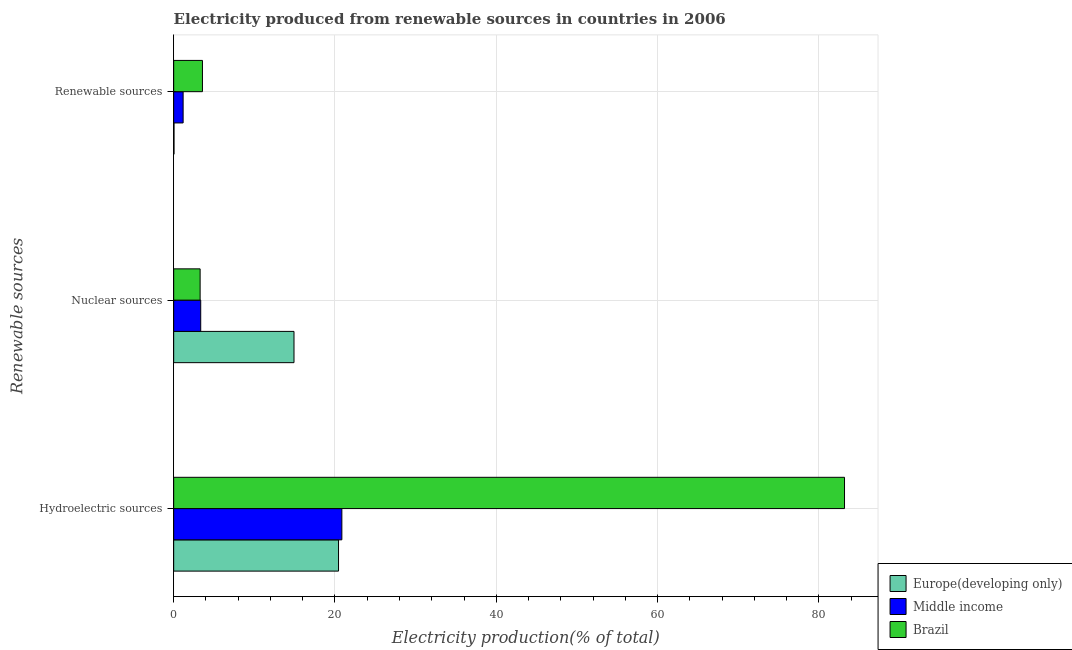How many groups of bars are there?
Give a very brief answer. 3. Are the number of bars per tick equal to the number of legend labels?
Make the answer very short. Yes. What is the label of the 2nd group of bars from the top?
Give a very brief answer. Nuclear sources. What is the percentage of electricity produced by hydroelectric sources in Europe(developing only)?
Your answer should be very brief. 20.44. Across all countries, what is the maximum percentage of electricity produced by nuclear sources?
Ensure brevity in your answer.  14.92. Across all countries, what is the minimum percentage of electricity produced by nuclear sources?
Make the answer very short. 3.28. In which country was the percentage of electricity produced by nuclear sources maximum?
Offer a terse response. Europe(developing only). In which country was the percentage of electricity produced by renewable sources minimum?
Provide a short and direct response. Europe(developing only). What is the total percentage of electricity produced by renewable sources in the graph?
Your answer should be very brief. 4.78. What is the difference between the percentage of electricity produced by hydroelectric sources in Middle income and that in Brazil?
Your answer should be compact. -62.33. What is the difference between the percentage of electricity produced by nuclear sources in Middle income and the percentage of electricity produced by hydroelectric sources in Europe(developing only)?
Provide a succinct answer. -17.09. What is the average percentage of electricity produced by hydroelectric sources per country?
Ensure brevity in your answer.  41.49. What is the difference between the percentage of electricity produced by hydroelectric sources and percentage of electricity produced by nuclear sources in Middle income?
Your answer should be very brief. 17.5. In how many countries, is the percentage of electricity produced by nuclear sources greater than 64 %?
Provide a short and direct response. 0. What is the ratio of the percentage of electricity produced by renewable sources in Middle income to that in Europe(developing only)?
Offer a terse response. 27.25. What is the difference between the highest and the second highest percentage of electricity produced by renewable sources?
Give a very brief answer. 2.4. What is the difference between the highest and the lowest percentage of electricity produced by hydroelectric sources?
Give a very brief answer. 62.74. Is the sum of the percentage of electricity produced by hydroelectric sources in Middle income and Europe(developing only) greater than the maximum percentage of electricity produced by renewable sources across all countries?
Offer a very short reply. Yes. What does the 3rd bar from the top in Renewable sources represents?
Your answer should be very brief. Europe(developing only). What does the 2nd bar from the bottom in Nuclear sources represents?
Make the answer very short. Middle income. Is it the case that in every country, the sum of the percentage of electricity produced by hydroelectric sources and percentage of electricity produced by nuclear sources is greater than the percentage of electricity produced by renewable sources?
Your answer should be very brief. Yes. Are all the bars in the graph horizontal?
Make the answer very short. Yes. How many countries are there in the graph?
Your answer should be compact. 3. What is the difference between two consecutive major ticks on the X-axis?
Give a very brief answer. 20. Are the values on the major ticks of X-axis written in scientific E-notation?
Your response must be concise. No. Does the graph contain grids?
Ensure brevity in your answer.  Yes. Where does the legend appear in the graph?
Keep it short and to the point. Bottom right. What is the title of the graph?
Give a very brief answer. Electricity produced from renewable sources in countries in 2006. What is the label or title of the Y-axis?
Your answer should be compact. Renewable sources. What is the Electricity production(% of total) in Europe(developing only) in Hydroelectric sources?
Your answer should be very brief. 20.44. What is the Electricity production(% of total) of Middle income in Hydroelectric sources?
Your response must be concise. 20.85. What is the Electricity production(% of total) of Brazil in Hydroelectric sources?
Offer a very short reply. 83.18. What is the Electricity production(% of total) of Europe(developing only) in Nuclear sources?
Offer a very short reply. 14.92. What is the Electricity production(% of total) of Middle income in Nuclear sources?
Your answer should be compact. 3.35. What is the Electricity production(% of total) in Brazil in Nuclear sources?
Make the answer very short. 3.28. What is the Electricity production(% of total) in Europe(developing only) in Renewable sources?
Your response must be concise. 0.04. What is the Electricity production(% of total) in Middle income in Renewable sources?
Your answer should be very brief. 1.17. What is the Electricity production(% of total) of Brazil in Renewable sources?
Give a very brief answer. 3.57. Across all Renewable sources, what is the maximum Electricity production(% of total) of Europe(developing only)?
Your response must be concise. 20.44. Across all Renewable sources, what is the maximum Electricity production(% of total) of Middle income?
Offer a very short reply. 20.85. Across all Renewable sources, what is the maximum Electricity production(% of total) in Brazil?
Give a very brief answer. 83.18. Across all Renewable sources, what is the minimum Electricity production(% of total) of Europe(developing only)?
Your answer should be compact. 0.04. Across all Renewable sources, what is the minimum Electricity production(% of total) in Middle income?
Offer a very short reply. 1.17. Across all Renewable sources, what is the minimum Electricity production(% of total) in Brazil?
Provide a short and direct response. 3.28. What is the total Electricity production(% of total) in Europe(developing only) in the graph?
Provide a short and direct response. 35.41. What is the total Electricity production(% of total) in Middle income in the graph?
Your answer should be very brief. 25.38. What is the total Electricity production(% of total) of Brazil in the graph?
Ensure brevity in your answer.  90.03. What is the difference between the Electricity production(% of total) in Europe(developing only) in Hydroelectric sources and that in Nuclear sources?
Offer a very short reply. 5.52. What is the difference between the Electricity production(% of total) in Middle income in Hydroelectric sources and that in Nuclear sources?
Provide a succinct answer. 17.5. What is the difference between the Electricity production(% of total) in Brazil in Hydroelectric sources and that in Nuclear sources?
Ensure brevity in your answer.  79.9. What is the difference between the Electricity production(% of total) in Europe(developing only) in Hydroelectric sources and that in Renewable sources?
Your response must be concise. 20.4. What is the difference between the Electricity production(% of total) of Middle income in Hydroelectric sources and that in Renewable sources?
Your answer should be compact. 19.68. What is the difference between the Electricity production(% of total) of Brazil in Hydroelectric sources and that in Renewable sources?
Your answer should be compact. 79.61. What is the difference between the Electricity production(% of total) of Europe(developing only) in Nuclear sources and that in Renewable sources?
Ensure brevity in your answer.  14.88. What is the difference between the Electricity production(% of total) of Middle income in Nuclear sources and that in Renewable sources?
Give a very brief answer. 2.18. What is the difference between the Electricity production(% of total) in Brazil in Nuclear sources and that in Renewable sources?
Your response must be concise. -0.29. What is the difference between the Electricity production(% of total) of Europe(developing only) in Hydroelectric sources and the Electricity production(% of total) of Middle income in Nuclear sources?
Offer a very short reply. 17.09. What is the difference between the Electricity production(% of total) of Europe(developing only) in Hydroelectric sources and the Electricity production(% of total) of Brazil in Nuclear sources?
Offer a very short reply. 17.16. What is the difference between the Electricity production(% of total) of Middle income in Hydroelectric sources and the Electricity production(% of total) of Brazil in Nuclear sources?
Make the answer very short. 17.57. What is the difference between the Electricity production(% of total) of Europe(developing only) in Hydroelectric sources and the Electricity production(% of total) of Middle income in Renewable sources?
Provide a succinct answer. 19.27. What is the difference between the Electricity production(% of total) in Europe(developing only) in Hydroelectric sources and the Electricity production(% of total) in Brazil in Renewable sources?
Provide a succinct answer. 16.87. What is the difference between the Electricity production(% of total) of Middle income in Hydroelectric sources and the Electricity production(% of total) of Brazil in Renewable sources?
Give a very brief answer. 17.29. What is the difference between the Electricity production(% of total) of Europe(developing only) in Nuclear sources and the Electricity production(% of total) of Middle income in Renewable sources?
Offer a very short reply. 13.75. What is the difference between the Electricity production(% of total) in Europe(developing only) in Nuclear sources and the Electricity production(% of total) in Brazil in Renewable sources?
Keep it short and to the point. 11.35. What is the difference between the Electricity production(% of total) of Middle income in Nuclear sources and the Electricity production(% of total) of Brazil in Renewable sources?
Your response must be concise. -0.21. What is the average Electricity production(% of total) in Europe(developing only) per Renewable sources?
Your response must be concise. 11.8. What is the average Electricity production(% of total) in Middle income per Renewable sources?
Provide a short and direct response. 8.46. What is the average Electricity production(% of total) of Brazil per Renewable sources?
Your answer should be very brief. 30.01. What is the difference between the Electricity production(% of total) of Europe(developing only) and Electricity production(% of total) of Middle income in Hydroelectric sources?
Your answer should be compact. -0.41. What is the difference between the Electricity production(% of total) of Europe(developing only) and Electricity production(% of total) of Brazil in Hydroelectric sources?
Make the answer very short. -62.74. What is the difference between the Electricity production(% of total) in Middle income and Electricity production(% of total) in Brazil in Hydroelectric sources?
Keep it short and to the point. -62.33. What is the difference between the Electricity production(% of total) of Europe(developing only) and Electricity production(% of total) of Middle income in Nuclear sources?
Give a very brief answer. 11.57. What is the difference between the Electricity production(% of total) in Europe(developing only) and Electricity production(% of total) in Brazil in Nuclear sources?
Your answer should be compact. 11.64. What is the difference between the Electricity production(% of total) of Middle income and Electricity production(% of total) of Brazil in Nuclear sources?
Offer a terse response. 0.07. What is the difference between the Electricity production(% of total) of Europe(developing only) and Electricity production(% of total) of Middle income in Renewable sources?
Your answer should be very brief. -1.13. What is the difference between the Electricity production(% of total) in Europe(developing only) and Electricity production(% of total) in Brazil in Renewable sources?
Your answer should be very brief. -3.52. What is the difference between the Electricity production(% of total) in Middle income and Electricity production(% of total) in Brazil in Renewable sources?
Your answer should be compact. -2.4. What is the ratio of the Electricity production(% of total) in Europe(developing only) in Hydroelectric sources to that in Nuclear sources?
Offer a very short reply. 1.37. What is the ratio of the Electricity production(% of total) of Middle income in Hydroelectric sources to that in Nuclear sources?
Offer a terse response. 6.22. What is the ratio of the Electricity production(% of total) in Brazil in Hydroelectric sources to that in Nuclear sources?
Give a very brief answer. 25.36. What is the ratio of the Electricity production(% of total) in Europe(developing only) in Hydroelectric sources to that in Renewable sources?
Your answer should be very brief. 475.44. What is the ratio of the Electricity production(% of total) in Middle income in Hydroelectric sources to that in Renewable sources?
Make the answer very short. 17.8. What is the ratio of the Electricity production(% of total) of Brazil in Hydroelectric sources to that in Renewable sources?
Offer a very short reply. 23.32. What is the ratio of the Electricity production(% of total) of Europe(developing only) in Nuclear sources to that in Renewable sources?
Your answer should be very brief. 347.03. What is the ratio of the Electricity production(% of total) of Middle income in Nuclear sources to that in Renewable sources?
Give a very brief answer. 2.86. What is the ratio of the Electricity production(% of total) of Brazil in Nuclear sources to that in Renewable sources?
Ensure brevity in your answer.  0.92. What is the difference between the highest and the second highest Electricity production(% of total) of Europe(developing only)?
Keep it short and to the point. 5.52. What is the difference between the highest and the second highest Electricity production(% of total) in Middle income?
Ensure brevity in your answer.  17.5. What is the difference between the highest and the second highest Electricity production(% of total) of Brazil?
Your answer should be compact. 79.61. What is the difference between the highest and the lowest Electricity production(% of total) in Europe(developing only)?
Offer a very short reply. 20.4. What is the difference between the highest and the lowest Electricity production(% of total) of Middle income?
Provide a succinct answer. 19.68. What is the difference between the highest and the lowest Electricity production(% of total) in Brazil?
Your answer should be compact. 79.9. 